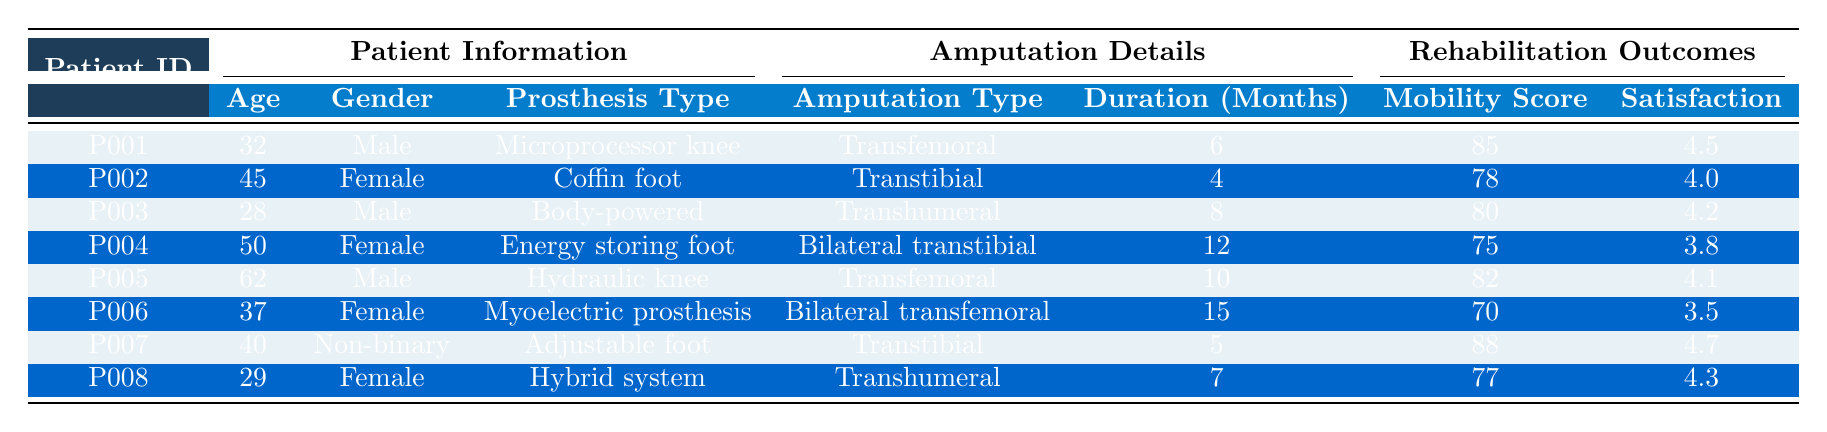What is the mobility score of Patient P007? The mobility score for Patient P007 can be found in the table under the Rehabilitation Outcomes section. It is listed as 88.
Answer: 88 What is the satisfaction rating for the individual with a bilateral transfemoral amputation? To find this, you need to look for the patient with a bilateral transfemoral amputation in the Amputation Details section. Patient P006 corresponds to this type and has a satisfaction rating of 3.5.
Answer: 3.5 Which prosthesis type is used by the youngest patient? The youngest patient is Patient P008, who is 29 years old. Referring to the Prosthesis Type section, Patient P008 uses a Hybrid system.
Answer: Hybrid system What is the average satisfaction rating for all patients? First, you sum the satisfaction ratings of all patients: (4.5 + 4.0 + 4.2 + 3.8 + 4.1 + 3.5 + 4.7 + 4.3) = 33.1. There are 8 patients, so the average is 33.1/8 = 4.1375, which rounds to 4.14.
Answer: 4.14 Does any patient have a satisfaction rating below 4.0? By examining the Satisfaction Ratings, you see that Patient P004 has a rating of 3.8, and Patient P006 has a rating of 3.5. Therefore, yes, there are patients with ratings below 4.0.
Answer: Yes How many patients have a mobility score greater than 80? Looking at the Mobility Scores, you find that Patients P001 (85), P005 (82), and P007 (88) all have scores above 80. Thus, there are three patients fitting this criterion.
Answer: 3 Which gender has the highest average satisfaction rating among patients? First, separate the patients by gender and then calculate their average satisfaction ratings: Males (4.5, 4.2, 4.1) average to 4.3; Females (4.0, 3.8, 3.5, 4.3) average to 3.9; Non-binary (4.7) stands alone. The highest average is for Males at 4.3.
Answer: Male What is the total rehabilitation duration for all patients? Adding the rehabilitation duration for each patient gives you: (6 + 4 + 8 + 12 + 10 + 15 + 5 + 7) = 67 months.
Answer: 67 months Is there any functional prosthesis type used by a patient with a satisfaction rating of 4.7? Yes, Patient P007 uses an Adjustable foot prosthesis with a satisfaction rating of 4.7.
Answer: Yes Which patient has the longest rehabilitation duration, and what is it? Patient P006 has the longest rehabilitation duration at 15 months listed under the Rehabilitation Details section.
Answer: 15 months 